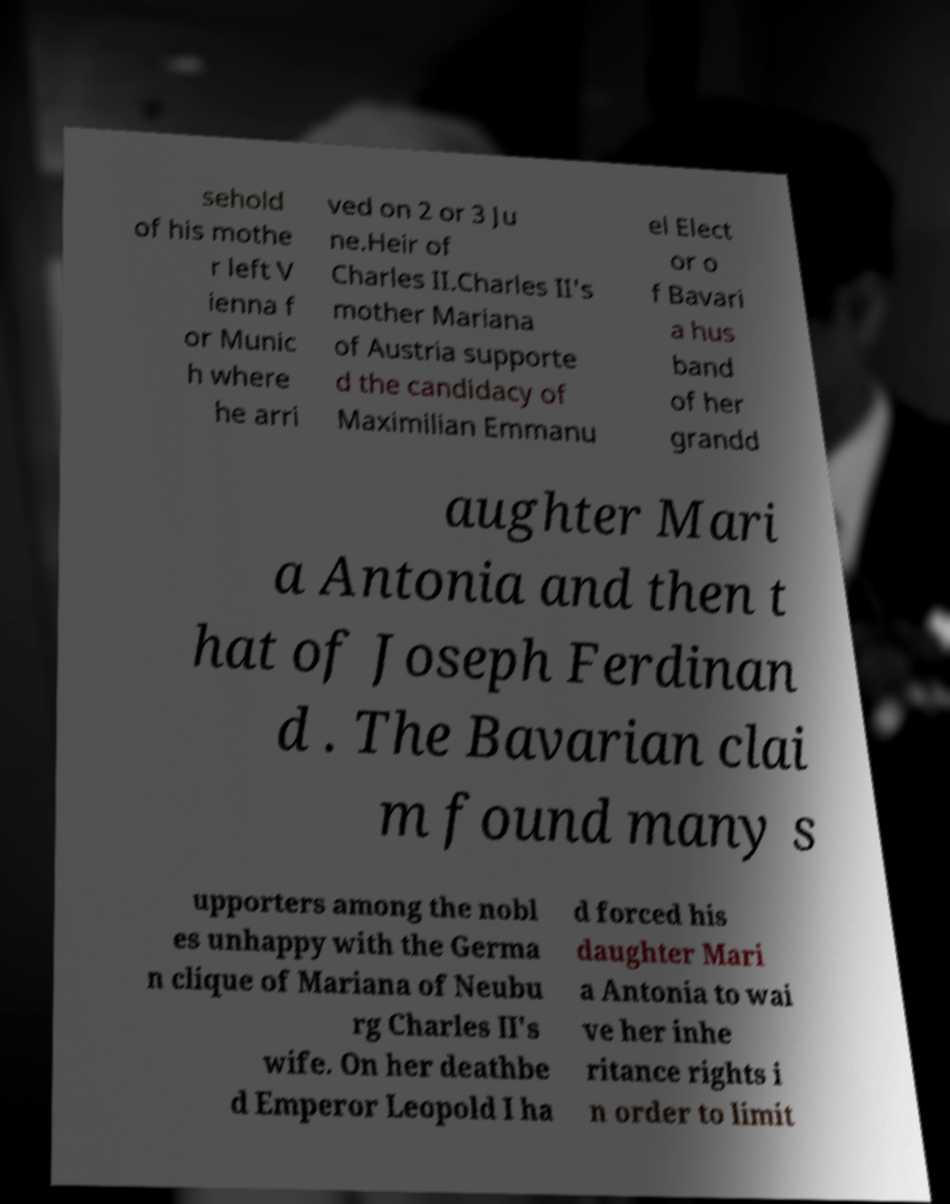Please read and relay the text visible in this image. What does it say? sehold of his mothe r left V ienna f or Munic h where he arri ved on 2 or 3 Ju ne.Heir of Charles II.Charles II's mother Mariana of Austria supporte d the candidacy of Maximilian Emmanu el Elect or o f Bavari a hus band of her grandd aughter Mari a Antonia and then t hat of Joseph Ferdinan d . The Bavarian clai m found many s upporters among the nobl es unhappy with the Germa n clique of Mariana of Neubu rg Charles II's wife. On her deathbe d Emperor Leopold I ha d forced his daughter Mari a Antonia to wai ve her inhe ritance rights i n order to limit 